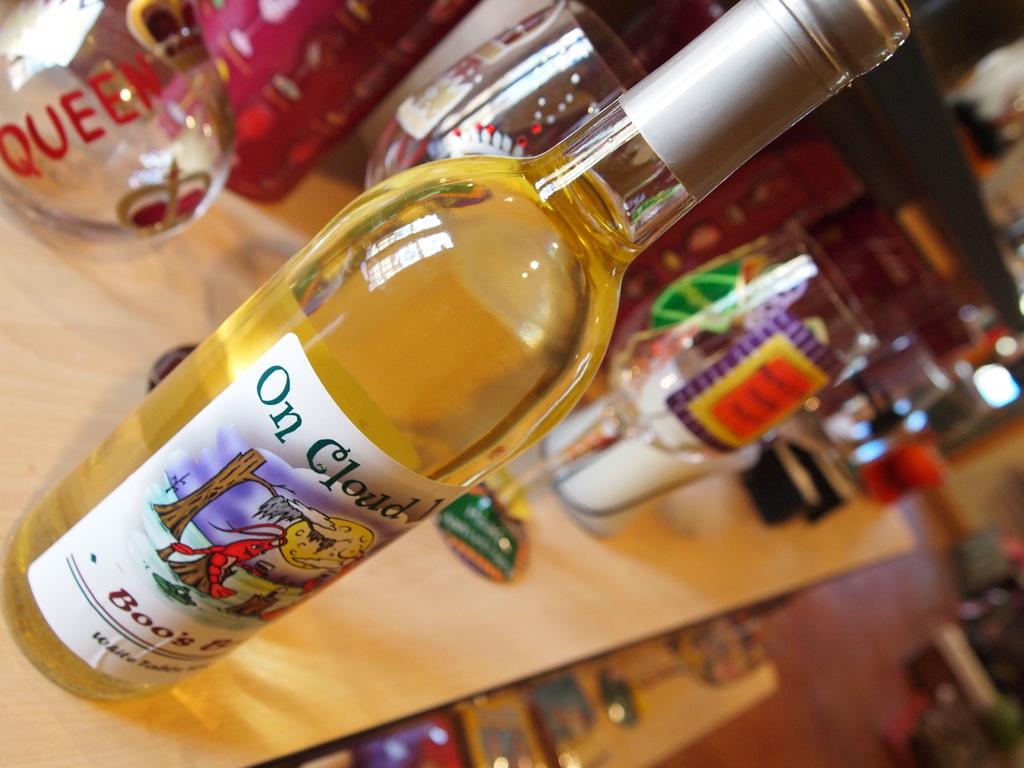What is on the clear bottle?
Give a very brief answer. Queen. 